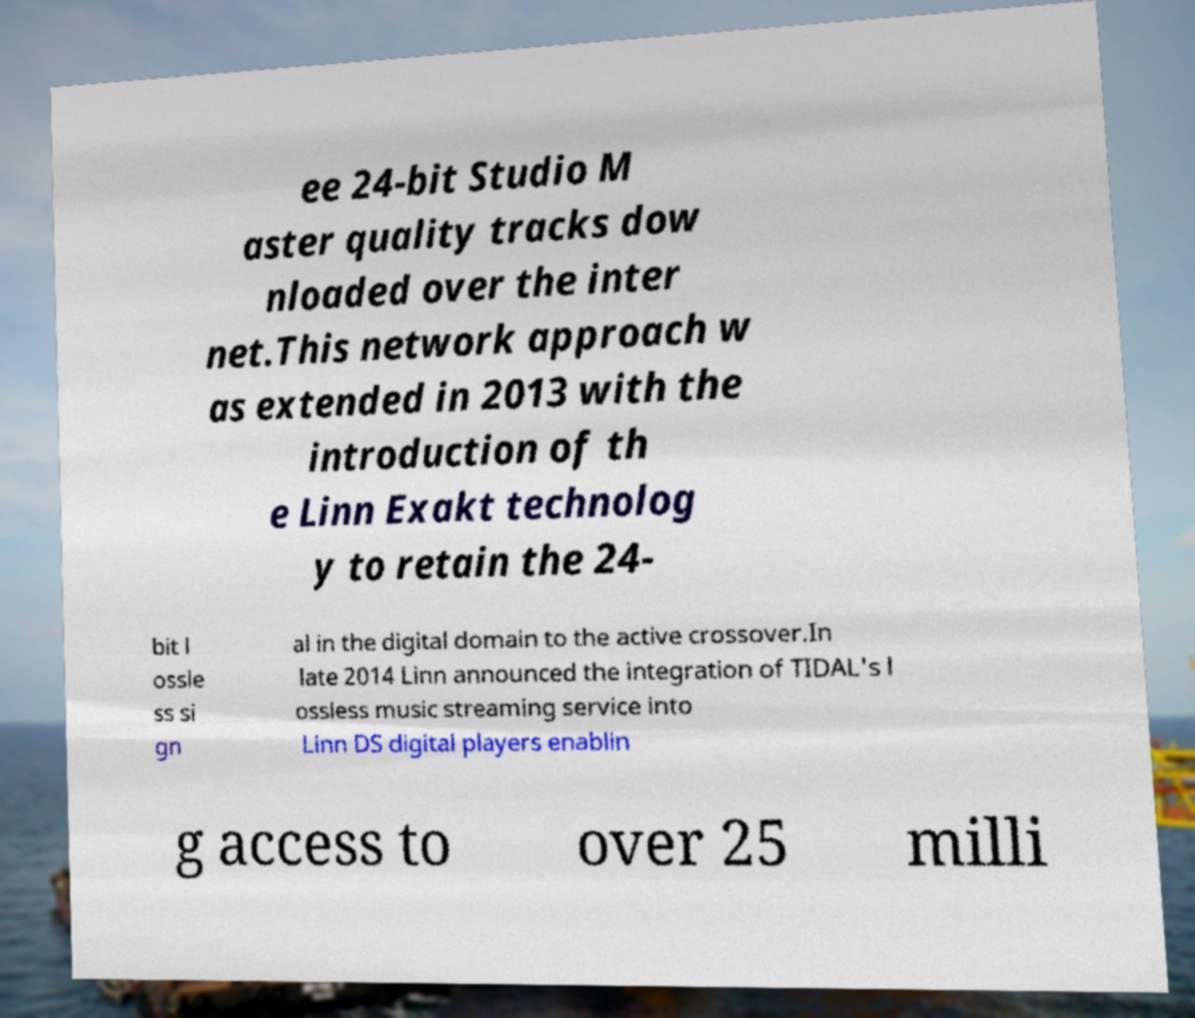Please read and relay the text visible in this image. What does it say? ee 24-bit Studio M aster quality tracks dow nloaded over the inter net.This network approach w as extended in 2013 with the introduction of th e Linn Exakt technolog y to retain the 24- bit l ossle ss si gn al in the digital domain to the active crossover.In late 2014 Linn announced the integration of TIDAL's l ossless music streaming service into Linn DS digital players enablin g access to over 25 milli 